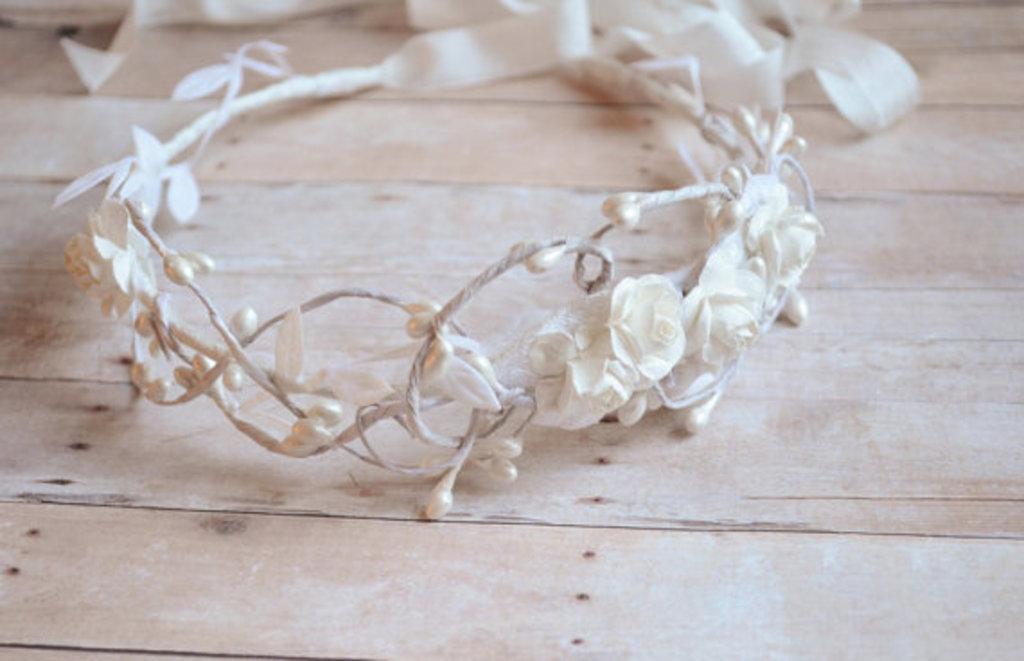In one or two sentences, can you explain what this image depicts? In this image we can see there is a table, on the table there is a tiara. 